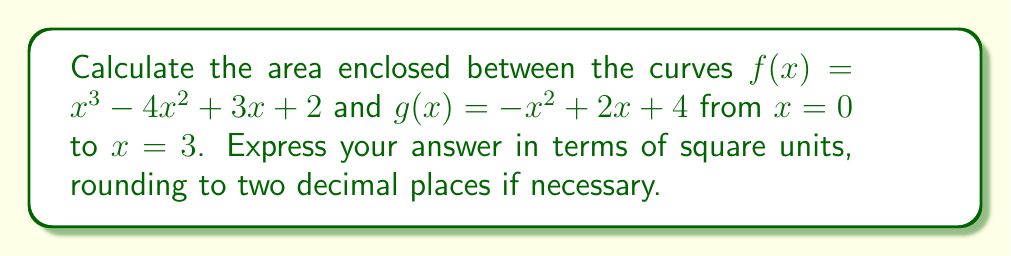Solve this math problem. To find the area between two curves, we need to follow these steps:

1) First, determine which function is 'on top' by subtracting $g(x)$ from $f(x)$:

   $f(x) - g(x) = (x^3 - 4x^2 + 3x + 2) - (-x^2 + 2x + 4)$
                = $x^3 - 3x^2 + x - 2$

2) The area between the curves is given by the definite integral of this difference:

   $$\text{Area} = \int_0^3 (f(x) - g(x)) \, dx = \int_0^3 (x^3 - 3x^2 + x - 2) \, dx$$

3) Integrate the polynomial:

   $$\int_0^3 (x^3 - 3x^2 + x - 2) \, dx = \left[\frac{x^4}{4} - x^3 + \frac{x^2}{2} - 2x\right]_0^3$$

4) Evaluate the integral at the limits:

   $\left(\frac{3^4}{4} - 3^3 + \frac{3^2}{2} - 2(3)\right) - \left(\frac{0^4}{4} - 0^3 + \frac{0^2}{2} - 2(0)\right)$

   $= \left(\frac{81}{4} - 27 + \frac{9}{2} - 6\right) - (0)$

   $= 20.25 - 27 + 4.5 - 6$

   $= -8.25$

5) Take the absolute value of this result, as area is always positive:

   $|\text{Area}| = |{-8.25}| = 8.25$

Therefore, the area between the curves from $x = 0$ to $x = 3$ is 8.25 square units.
Answer: 8.25 square units 